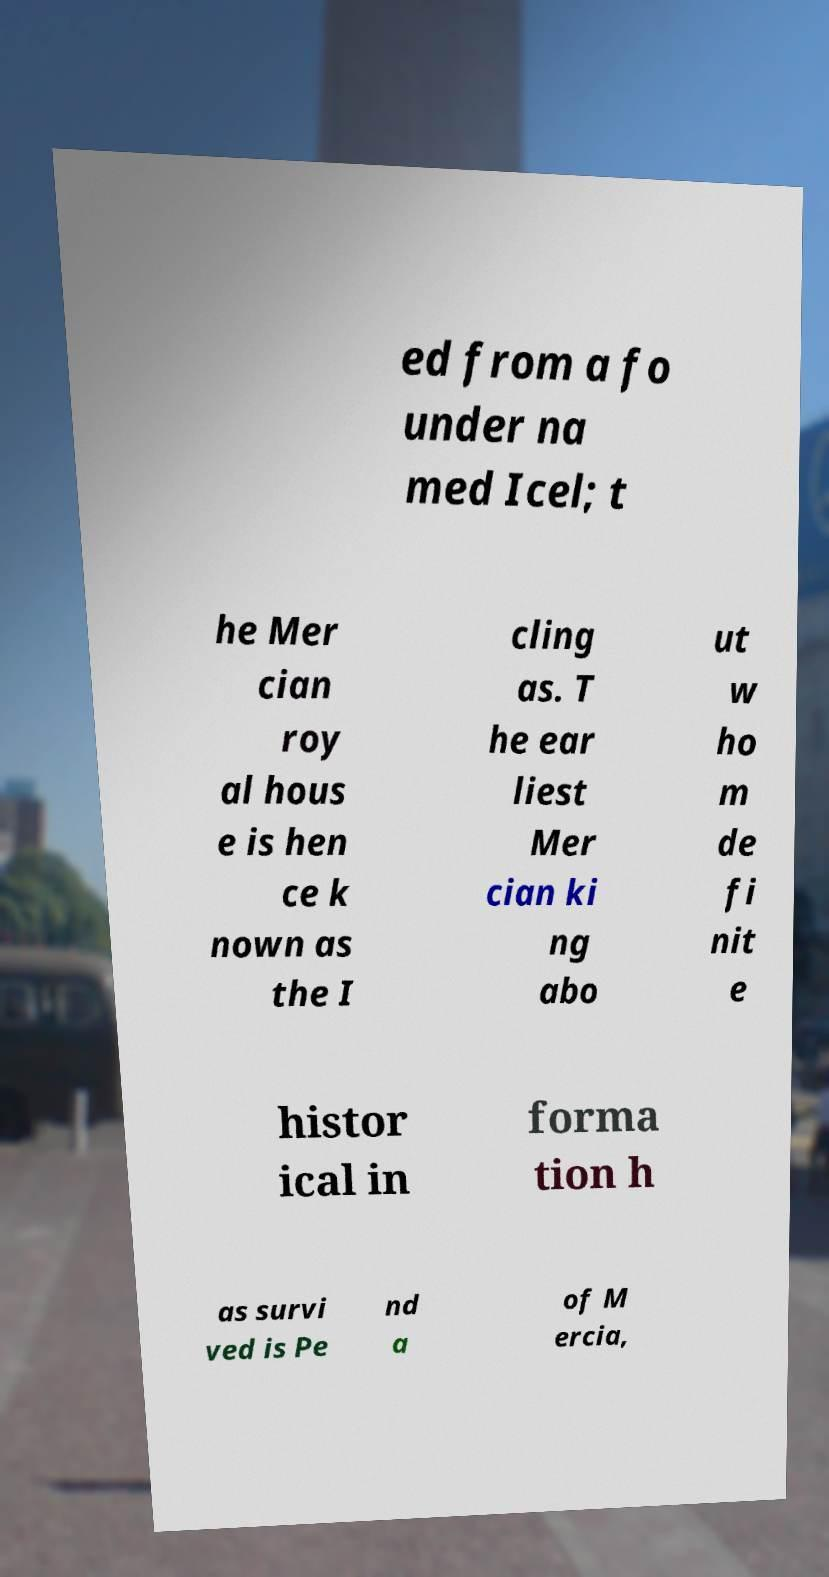Please identify and transcribe the text found in this image. ed from a fo under na med Icel; t he Mer cian roy al hous e is hen ce k nown as the I cling as. T he ear liest Mer cian ki ng abo ut w ho m de fi nit e histor ical in forma tion h as survi ved is Pe nd a of M ercia, 